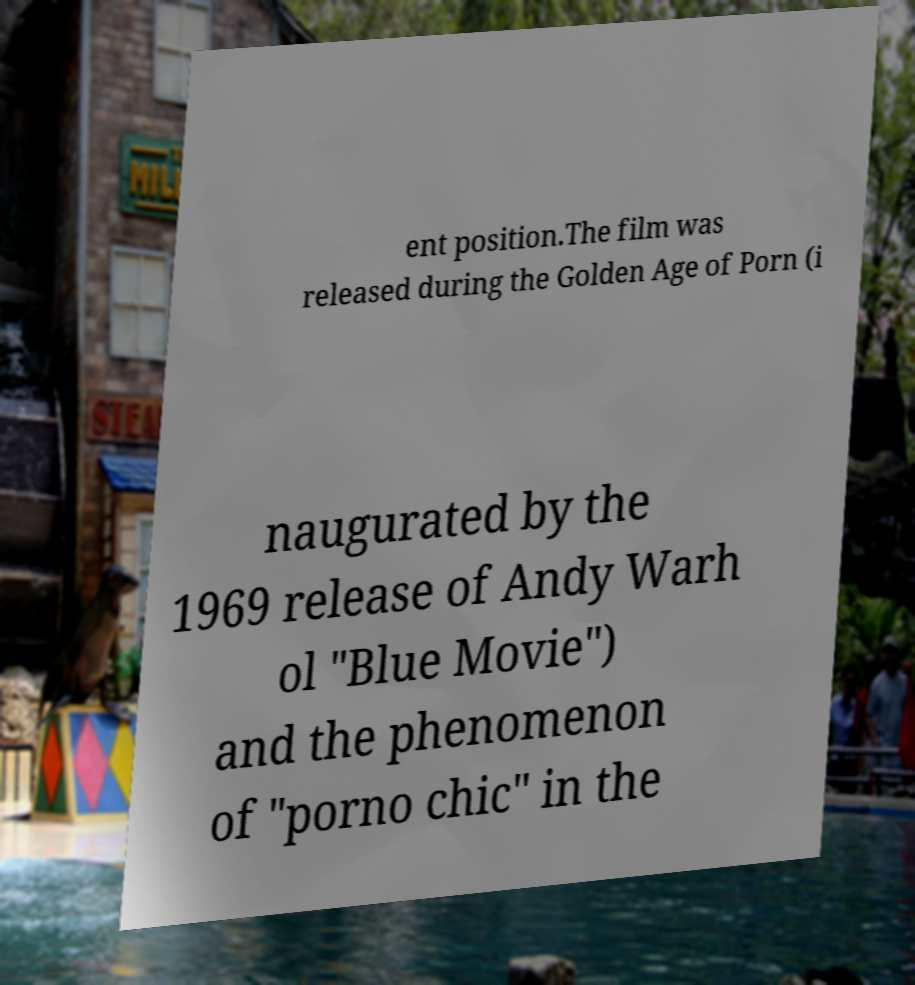For documentation purposes, I need the text within this image transcribed. Could you provide that? ent position.The film was released during the Golden Age of Porn (i naugurated by the 1969 release of Andy Warh ol "Blue Movie") and the phenomenon of "porno chic" in the 